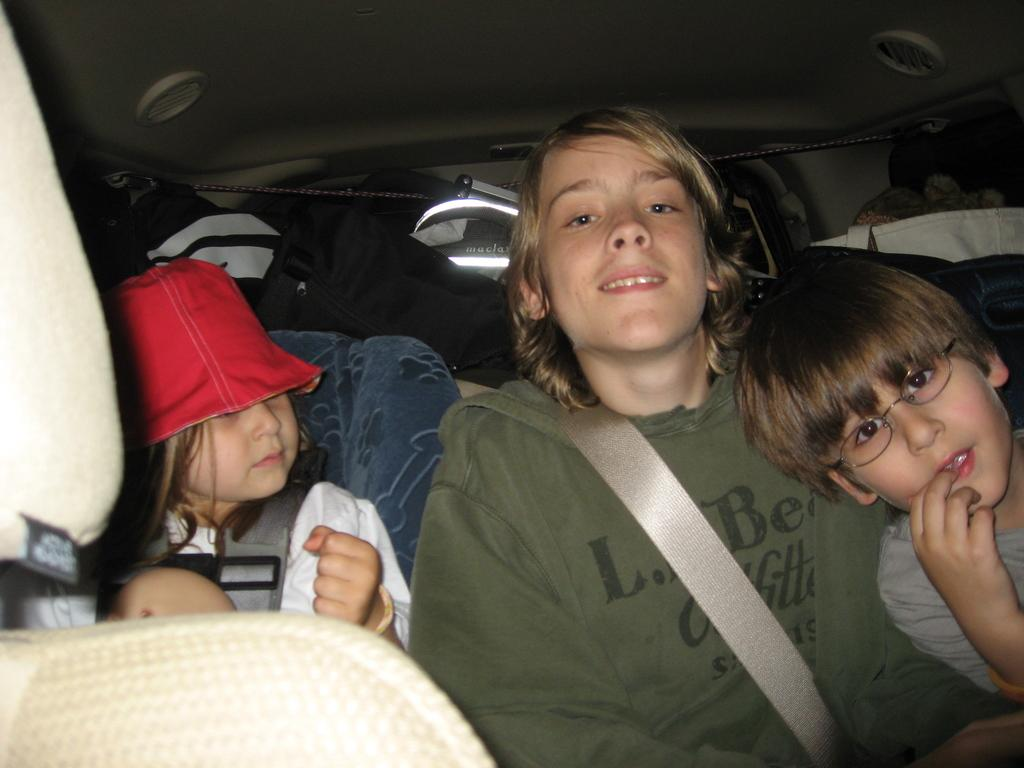What are the people in the image doing? The people in the image are sitting in a car. Are the people in the car following any safety precautions? Yes, the people in the car are wearing seat belts. Can you describe the girl in the car? The girl in the car is wearing a red-colored cap. What type of arithmetic problem is the girl solving in the car? There is no indication in the image that the girl is solving an arithmetic problem. What kind of suit is the girl wearing in the car? The girl is not wearing a suit in the image; she is wearing a red-colored cap. 